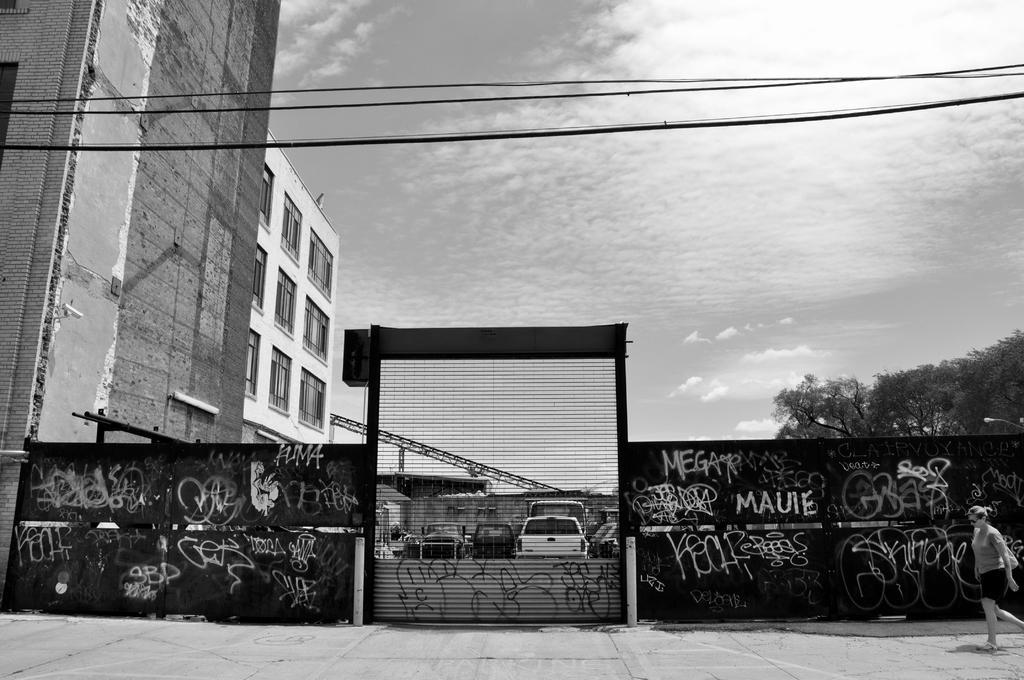Please provide a concise description of this image. In the foreground I can see a woman on the road, wall fence and fleets of cars. In the background I can see buildings, wires and the sky. This image is taken on the road. 